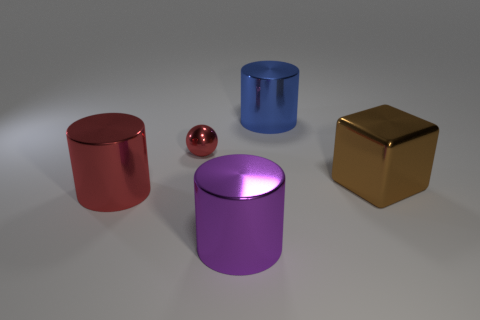Add 5 purple metal things. How many objects exist? 10 Subtract all cubes. How many objects are left? 4 Add 1 large cubes. How many large cubes are left? 2 Add 1 small cyan cylinders. How many small cyan cylinders exist? 1 Subtract 0 blue balls. How many objects are left? 5 Subtract all large blue shiny things. Subtract all red matte balls. How many objects are left? 4 